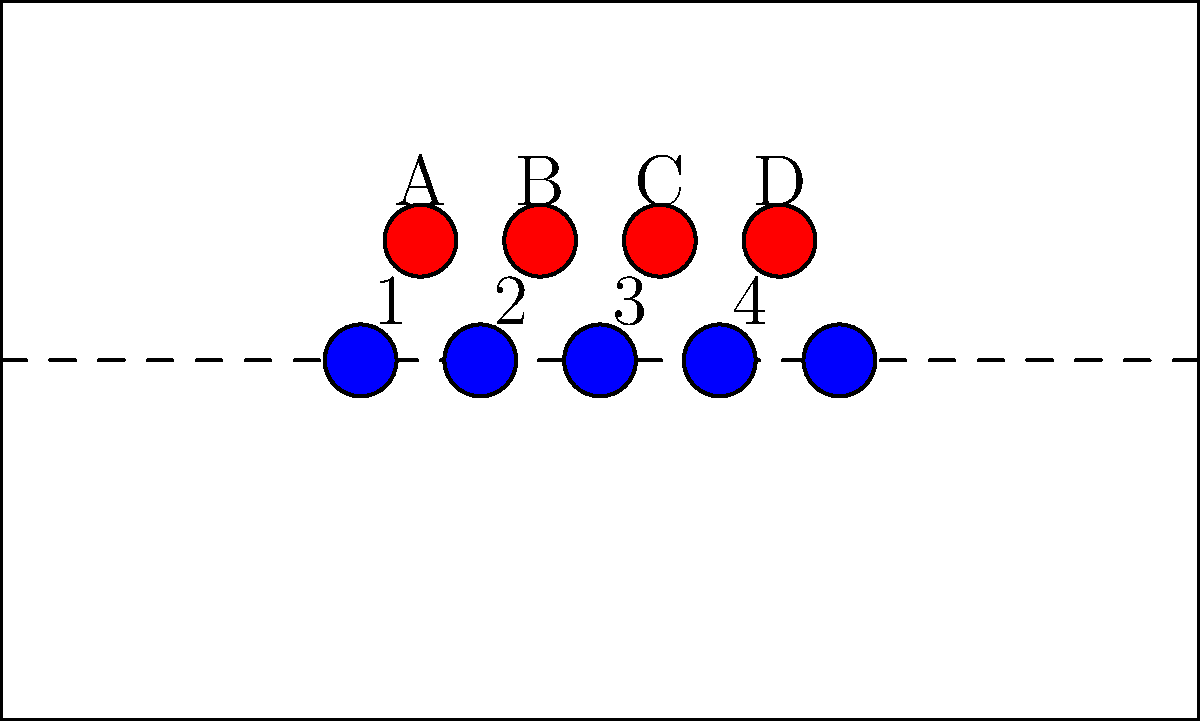In the diagram above, which defensive player is responsible for controlling the "3" gap in a typical 4-3 defensive alignment? To answer this question, we need to understand gap control techniques in a 4-3 defensive alignment:

1. In a 4-3 defense, there are four defensive linemen and three linebackers.
2. The gaps are numbered from the center outward, with the "0" gap being directly over the center (not shown in this diagram).
3. The "1" gap is between the center and guard, "2" gap is between guard and tackle, "3" gap is outside the tackle, and "4" gap is outside the tight end.
4. In a typical 4-3 alignment, the defensive linemen are responsible for the gaps as follows:
   - The defensive tackles (B and C) are usually responsible for the "1" gaps.
   - The defensive ends (A and D) are typically responsible for the "3" gaps.
5. In this diagram, the "3" gap on the right side of the offense is between the offensive tackle and tight end.
6. The defensive player closest to this gap is player D, the right defensive end.

Therefore, in a typical 4-3 defensive alignment, the player responsible for controlling the "3" gap on the right side is the right defensive end, labeled as D in the diagram.
Answer: D 